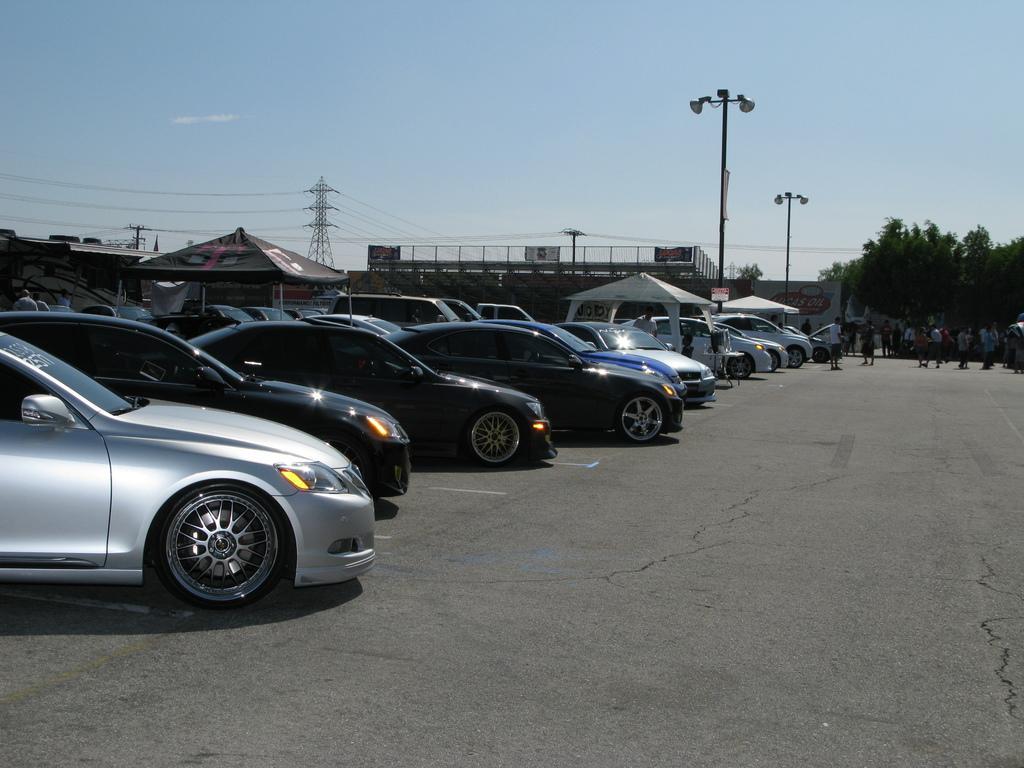Could you give a brief overview of what you see in this image? In this image I can see few vehicles and I can see group of people standing. In the background I can see the tent, few buildings, light poles, trees in green color and I can also see the tower and the sky is in blue and white color. 